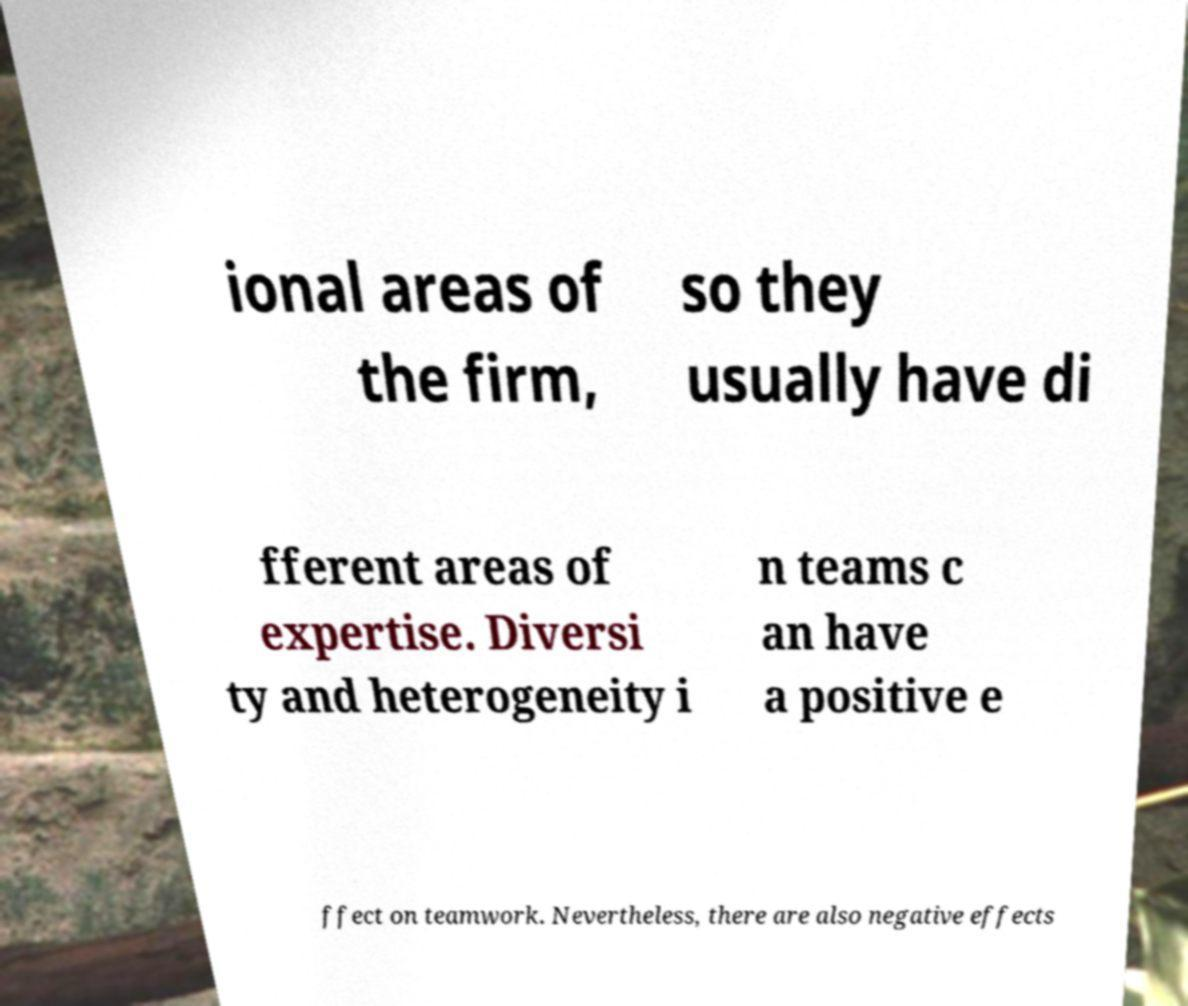Please identify and transcribe the text found in this image. ional areas of the firm, so they usually have di fferent areas of expertise. Diversi ty and heterogeneity i n teams c an have a positive e ffect on teamwork. Nevertheless, there are also negative effects 